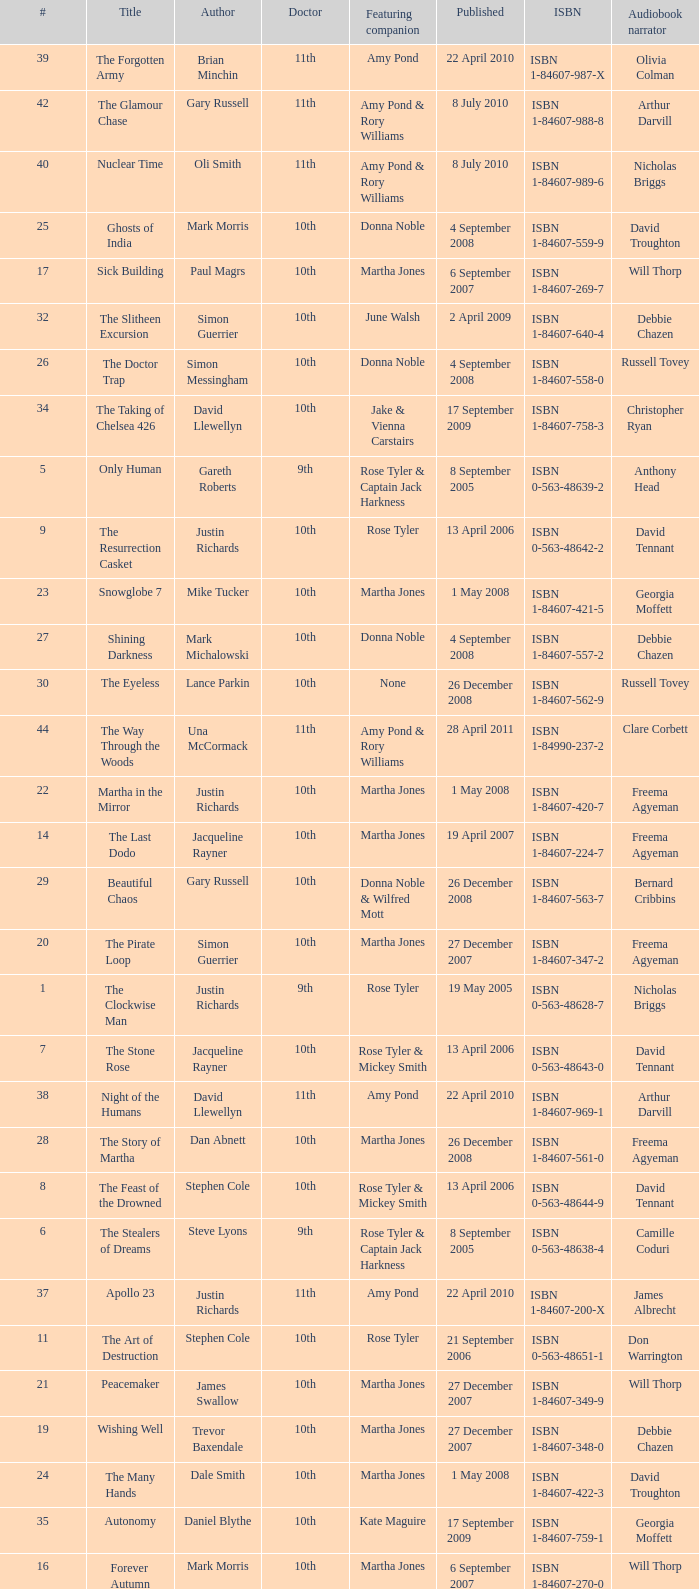What is the title of ISBN 1-84990-243-7? The Silent Stars Go By. 